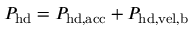<formula> <loc_0><loc_0><loc_500><loc_500>P _ { h d } = P _ { h d , a c c } + P _ { h d , v e l , b }</formula> 